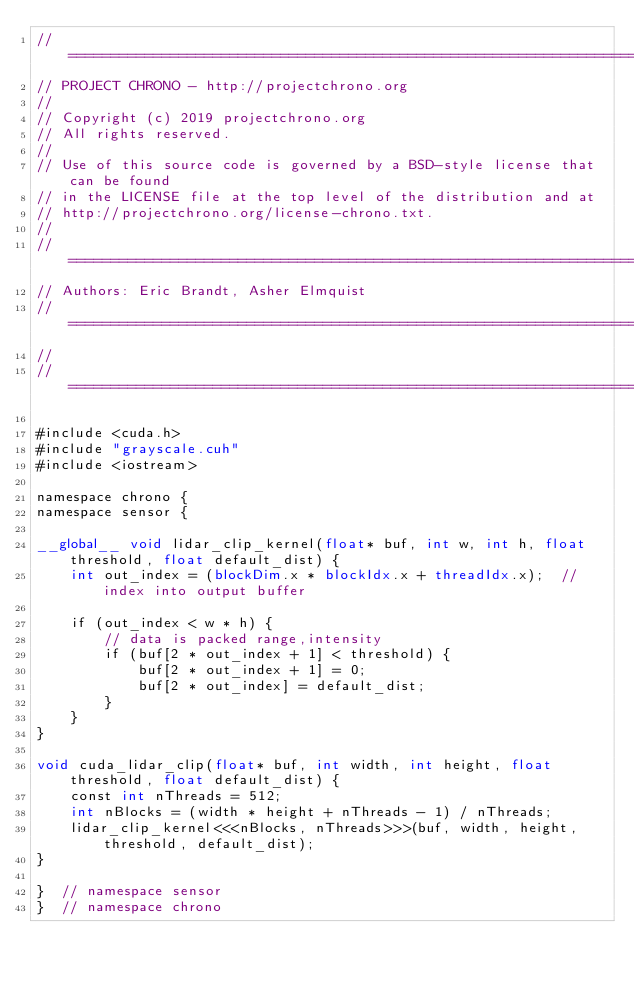<code> <loc_0><loc_0><loc_500><loc_500><_Cuda_>// =============================================================================
// PROJECT CHRONO - http://projectchrono.org
//
// Copyright (c) 2019 projectchrono.org
// All rights reserved.
//
// Use of this source code is governed by a BSD-style license that can be found
// in the LICENSE file at the top level of the distribution and at
// http://projectchrono.org/license-chrono.txt.
//
// =============================================================================
// Authors: Eric Brandt, Asher Elmquist
// =============================================================================
//
// =============================================================================

#include <cuda.h>
#include "grayscale.cuh"
#include <iostream>

namespace chrono {
namespace sensor {

__global__ void lidar_clip_kernel(float* buf, int w, int h, float threshold, float default_dist) {
    int out_index = (blockDim.x * blockIdx.x + threadIdx.x);  // index into output buffer

    if (out_index < w * h) {
        // data is packed range,intensity
        if (buf[2 * out_index + 1] < threshold) {
            buf[2 * out_index + 1] = 0;
            buf[2 * out_index] = default_dist;
        }
    }
}

void cuda_lidar_clip(float* buf, int width, int height, float threshold, float default_dist) {
    const int nThreads = 512;
    int nBlocks = (width * height + nThreads - 1) / nThreads;
    lidar_clip_kernel<<<nBlocks, nThreads>>>(buf, width, height, threshold, default_dist);
}

}  // namespace sensor
}  // namespace chrono
</code> 